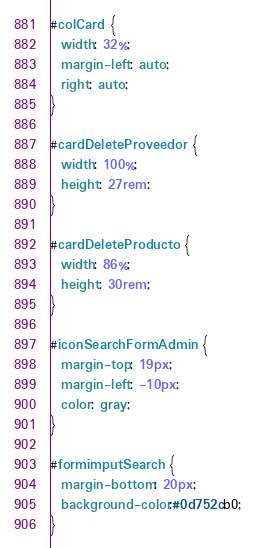<code> <loc_0><loc_0><loc_500><loc_500><_CSS_>#colCard {
  width: 32%;
  margin-left: auto;
  right: auto;
}

#cardDeleteProveedor {
  width: 100%;
  height: 27rem;
}

#cardDeleteProducto {
  width: 86%;
  height: 30rem;
}

#iconSearchFormAdmin {
  margin-top: 19px;
  margin-left: -10px;
  color: gray;
}

#formimputSearch {
  margin-bottom: 20px;
  background-color:#0d752cb0;
}
</code> 